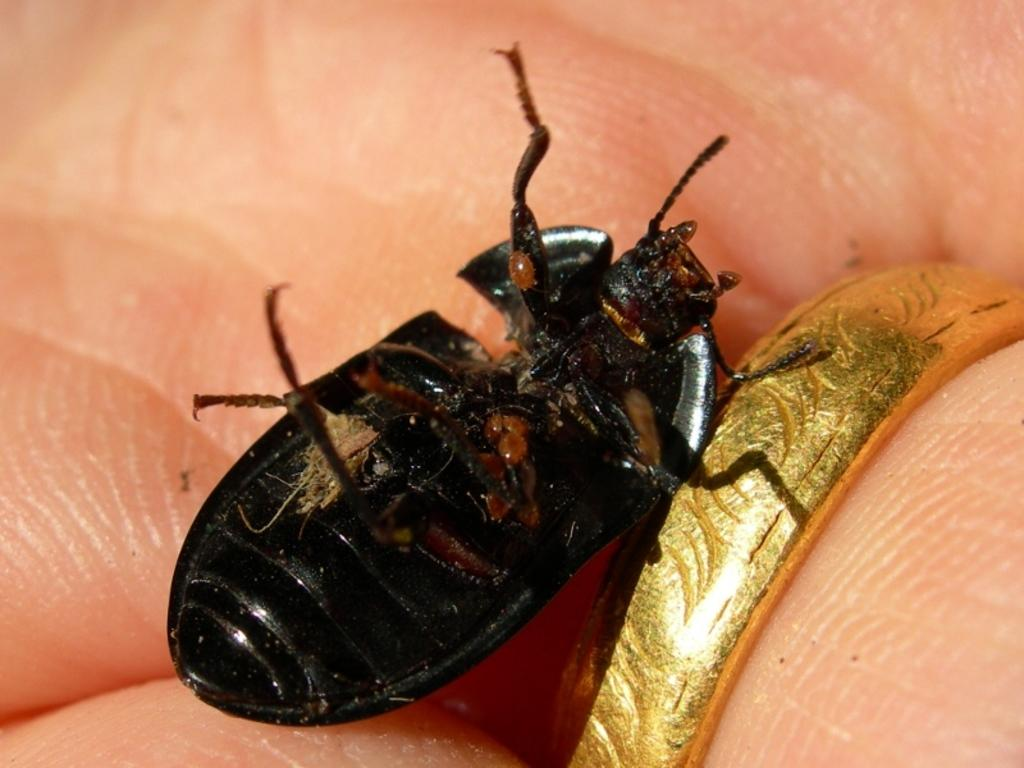What type of creature is in the image? There is an insect in the image. What colors can be seen on the insect? The insect has black and brown coloring. Where is the insect located in the image? The insect is on a person's hand. What type of jewelry is visible in the image? There is a gold-colored ring on a finger in the image. How many trucks can be seen in the image? There are no trucks present in the image. Is there a boat visible in the image? There is no boat present in the image. 